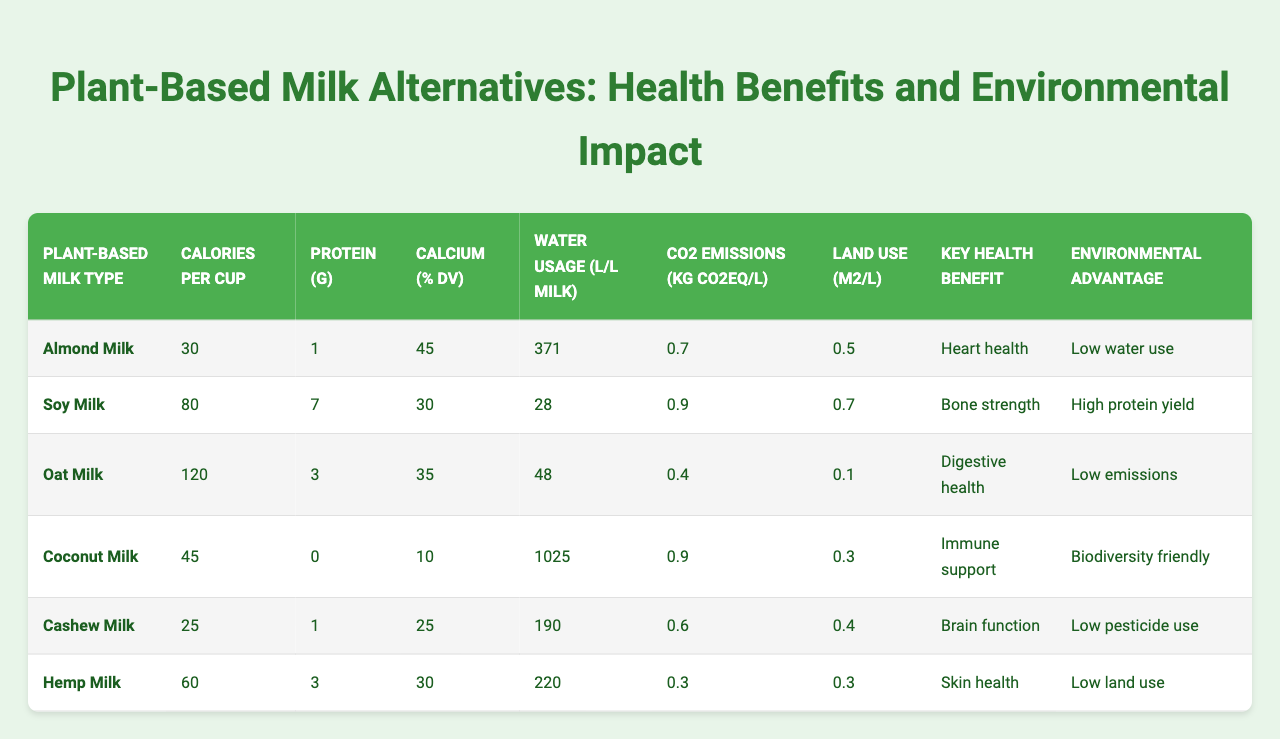What is the highest protein content among the plant-based milk alternatives? Looking at the "Protein (g)" column, Soy Milk has the highest protein content with 7 grams per cup.
Answer: 7 grams Which plant-based milk has the lowest water usage per liter? The "Water Usage (L/L milk)" column shows Almond Milk with the lowest water usage of 371 liters per liter of milk.
Answer: 371 liters What is the average calcium percentage for the plant-based milk alternatives? The calcium percentages are 45, 30, 35, 10, 25, and 30. Adding these gives 175, and dividing by 6 entries results in an average of approximately 29.17%.
Answer: 29.17% True or False: Coconut Milk has the highest CO2 emissions. In the "CO2 Emissions (kg CO2eq/L)" column, both Almond Milk and Soy Milk have higher emissions than Coconut Milk, which lists 0.9 kg CO2eq/L. Therefore, the statement is false.
Answer: False Which plant-based milk alternative is associated with digestive health? Referring to the "Key Health Benefit" column, Oat Milk is noted for its digestive health benefits.
Answer: Oat Milk Which plant-based milk has the highest calories per cup? The "Calories per Cup" column shows Oat Milk has the highest calories at 120.
Answer: 120 calories Which plant-based milk type has the lowest land use? The "Land Use (m2/L)" column indicates that Oat Milk has the lowest land use at 0.1 m² per liter.
Answer: 0.1 m² What is the difference in CO2 emissions between Soy Milk and Hemp Milk? Looking at the "CO2 Emissions (kg CO2eq/L)" column, Soy Milk has 0.9 kg CO2eq/L and Hemp Milk has 0.3 kg CO2eq/L. The difference is 0.9 - 0.3 = 0.6 kg CO2eq/L.
Answer: 0.6 kg CO2eq/L Which milk alternative has the key health benefit of skin health? According to the "Key Health Benefit" column, Hemp Milk is associated with skin health.
Answer: Hemp Milk Which plant-based milk has the environmental advantage of high protein yield? The "Environmental Advantage" column indicates that Soy Milk offers a high protein yield.
Answer: Soy Milk 